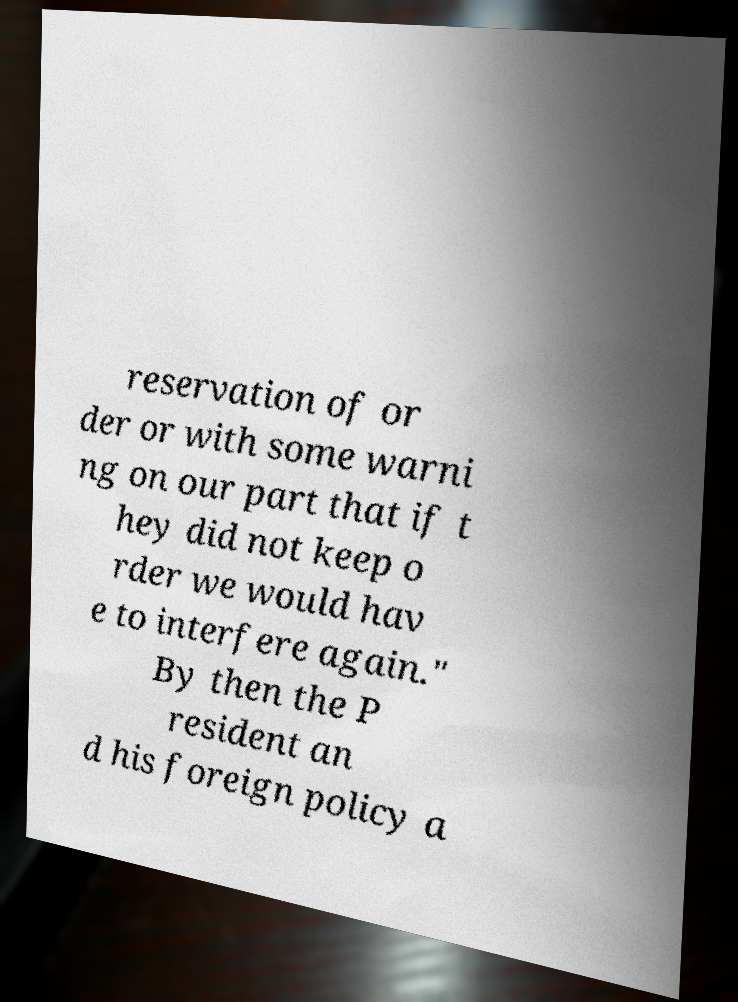Can you read and provide the text displayed in the image?This photo seems to have some interesting text. Can you extract and type it out for me? reservation of or der or with some warni ng on our part that if t hey did not keep o rder we would hav e to interfere again." By then the P resident an d his foreign policy a 